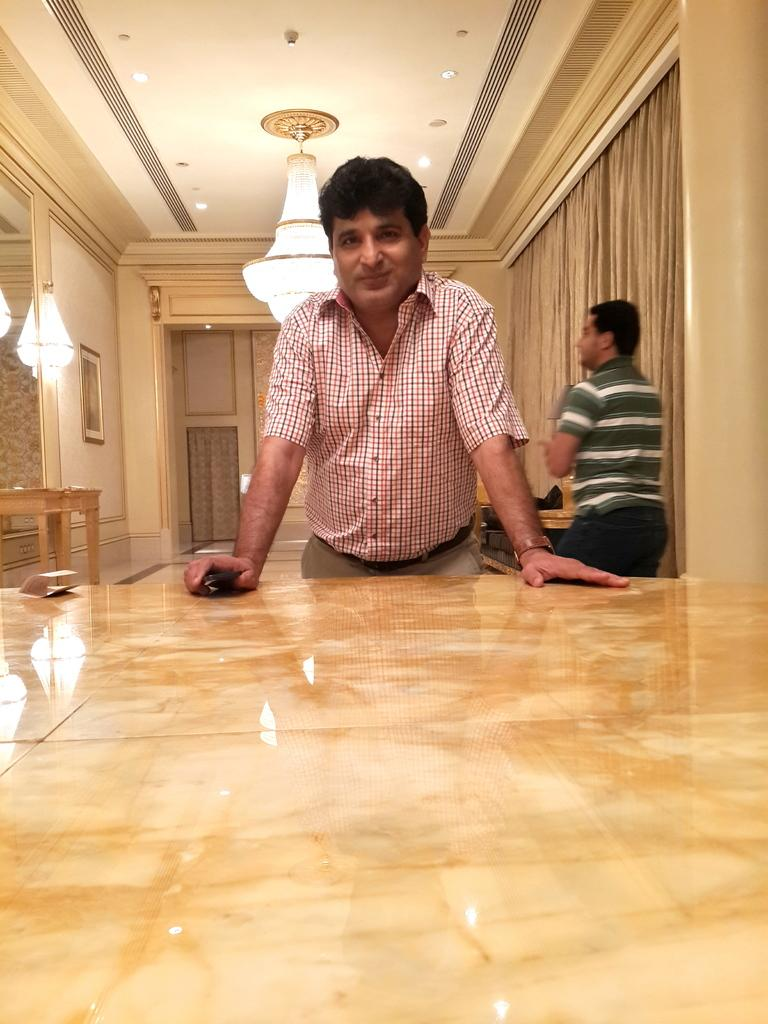How many people are in the image? There are two persons standing in the image. What can be seen above the persons in the image? There is a roof in the image. What is providing illumination in the image? There are lights in the image. What is on the wall in the image? There is a frame on the wall. What is in front of the persons in the image? There is a table in front of the persons. What type of coal is being used to fuel the magic in the image? There is no coal or magic present in the image; it features two persons, a roof, lights, a wall, a frame, and a table. 